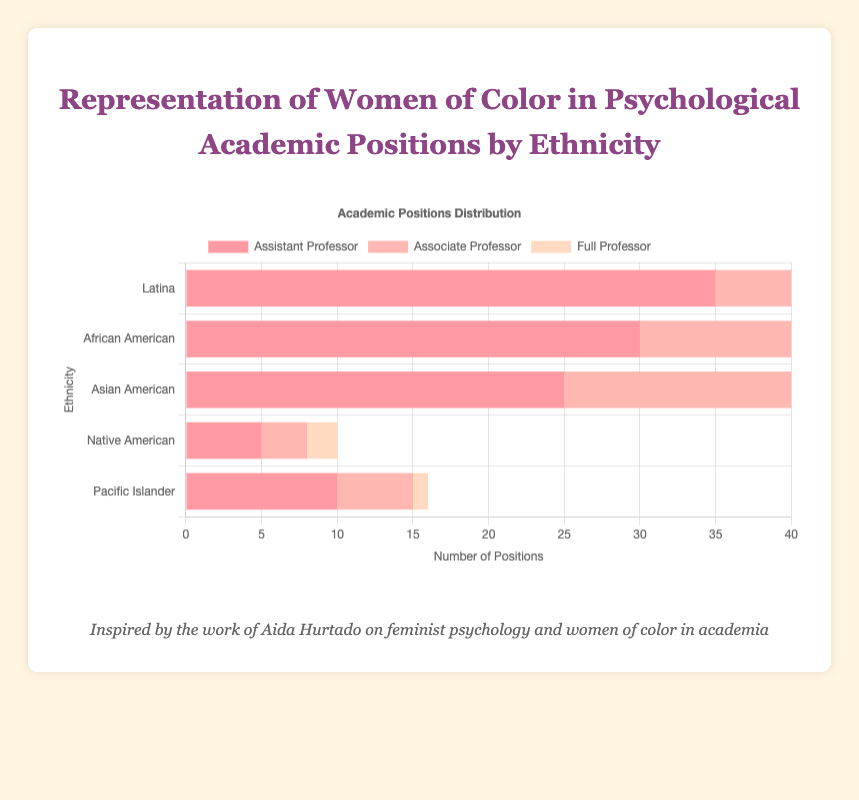Which ethnicity has the highest number of assistant professors? By looking at the horizontal bars for the assistant professor positions, we can see that the Latina group has the longest bar, indicating they have the highest number.
Answer: Latina What is the total number of associate professors across all ethnicities? Sum the number of associate professors for each ethnicity: 20 (Latina) + 18 (African American) + 15 (Asian American) + 3 (Native American) + 5 (Pacific Islander) = 61
Answer: 61 Compare the number of full professors who are African American and Asian American. Which group has more, and by how much? African American full professors are 12, and Asian American full professors are 8. The difference is 12 - 8 = 4 more for the African American group.
Answer: African American, 4 more Which position has the smallest representation for Native Americans and what is the number? The bar representing full professors for Native Americans is the shortest and thus the smallest representation, which is 2.
Answer: Full Professor, 2 What's the average number of full professors among Latina, African American and Asian American ethnicities? To find the average, sum the full professors of these three ethnicities: 10 (Latina) + 12 (African American) + 8 (Asian American) = 30. Then divide by 3: 30 / 3 = 10.
Answer: 10 Compare the total number of academic positions held by Pacific Islanders and Native Americans. Sum all positions for both groups. Pacific Islanders: 10 (Assistant) + 5 (Associate) + 1 (Full) = 16. Native Americans: 5 (Assistant) + 3 (Associate) + 2 (Full) = 10. Pacific Islanders have more: 16 - 10 = 6 more.
Answer: Pacific Islanders, 6 more What is the sum of assistant and associate professors for Asian Americans? Add the number of assistant professors (25) and associate professors (15) for Asian Americans: 25 + 15 = 40.
Answer: 40 What percentage of the total number of assistant professors do African Americans represent? The total number of assistant professors is 35 (Latina) + 30 (African American) + 25 (Asian American) + 5 (Native American) + 10 (Pacific Islander) = 105. The percentage African American assistant professors represent is (30 / 105) * 100% ≈ 28.57%.
Answer: 28.57% Which ethnic group shows the smallest overall representation in academic positions and what is the total number? Sum all positions for each ethnicity and compare. Native Americans have 5 (Assistant) + 3 (Associate) + 2 (Full) = 10, which is the smallest.
Answer: Native Americans, 10 